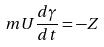Convert formula to latex. <formula><loc_0><loc_0><loc_500><loc_500>m U \frac { d \gamma } { d t } = - Z</formula> 